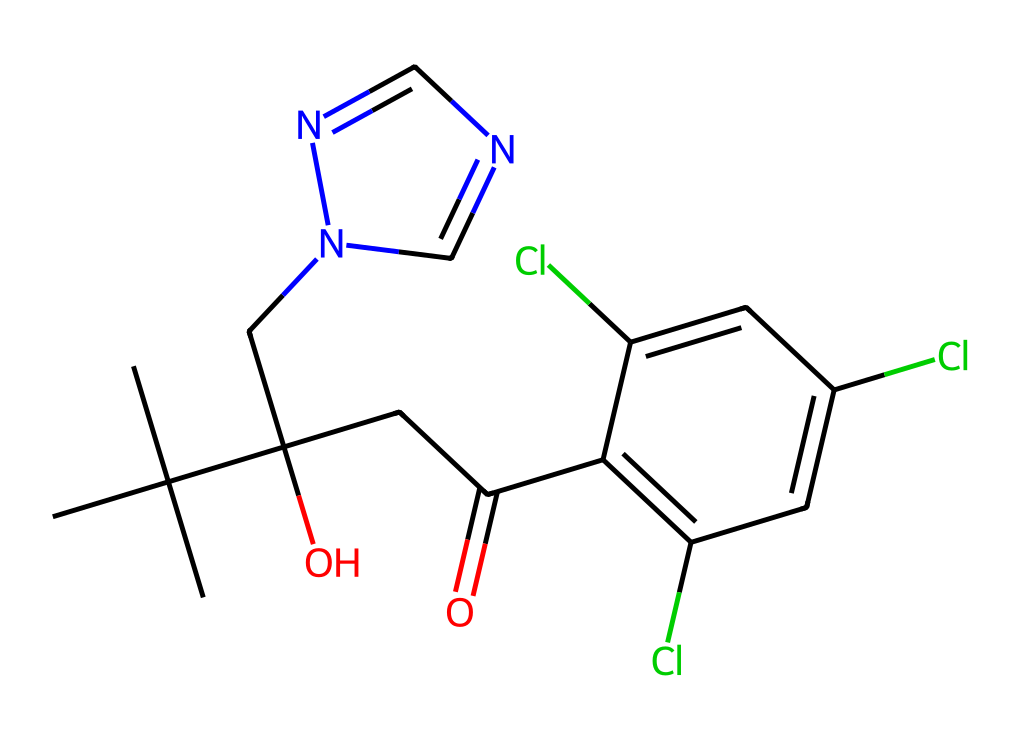What is the molecular formula of propiconazole? To find the molecular formula, we need to count the number of each type of atom in the SMILES representation. The structure comprises carbon (C), hydrogen (H), nitrogen (N), and chlorine (Cl) atoms. Counting them gives us C14, H17, N3, and Cl3. Thus, the molecular formula is C14H17Cl3N3O.
Answer: C14H17Cl3N3O How many chlorine atoms are present in propiconazole? By examining the SMILES notation, we can count the occurrences of the chlorine symbol (Cl). There are three instances, indicating the presence of three chlorine atoms.
Answer: 3 What functional groups are present in propiconazole? The structure contains several functional groups. The hydroxyl group (-OH) is identified from the part "C(O)", and the amine group (–NH) can be deduced from the nitrogen atoms in the side chain. We also observe a carbonyl group (C=O) from "CC(=O)".
Answer: hydroxyl, amine, carbonyl Is propiconazole a saturated or unsaturated compound? Looking at the structure, the presence of double bonds, especially in the aromatic ring indicates unsaturation. There are C=C bonds and a C=O bond in the structure, confirming that propiconazole is unsaturated.
Answer: unsaturated What is the primary function of propiconazole? As a fungicide, propiconazole is designed to inhibit the growth of fungi. Its chemical structure contains features that target fungal metabolism, preventing their growth and replication.
Answer: fungicide Does propiconazole contain any heteroatoms? Yes, heteroatoms are non-carbon atoms in a compound. The presence of nitrogen (N) and oxygen (O) in the structure indicates that propiconazole contains heteroatoms, making it a heterocyclic compound.
Answer: yes 